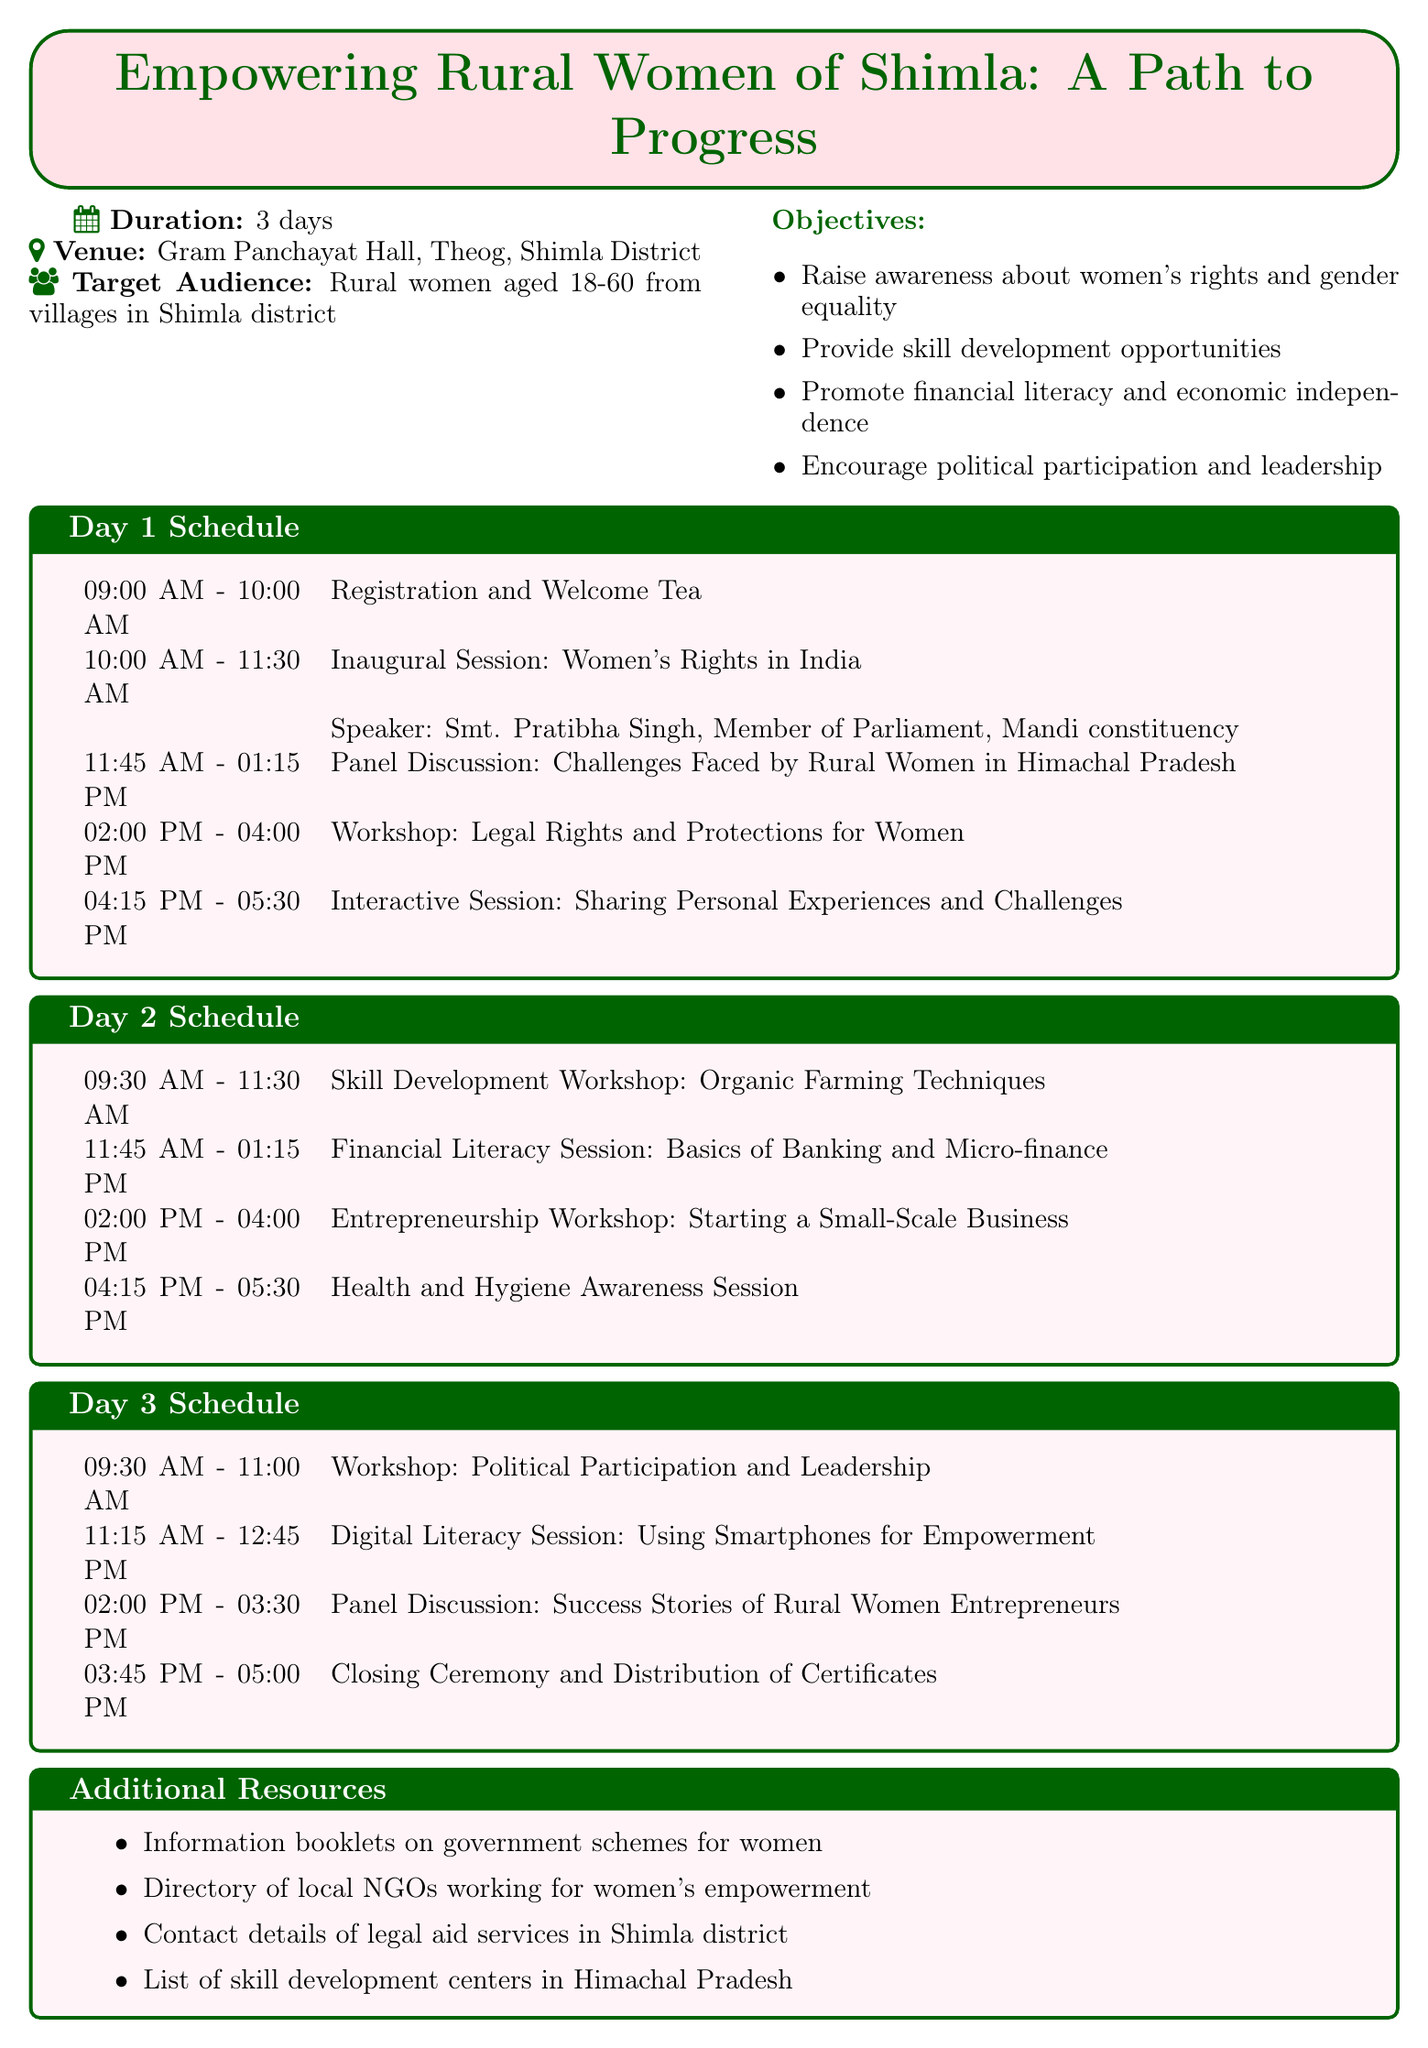What is the title of the workshop? The title is stated in the document as "Empowering Rural Women of Shimla: A Path to Progress."
Answer: Empowering Rural Women of Shimla: A Path to Progress What is the duration of the workshop? The duration is explicitly mentioned as "3 days."
Answer: 3 days Where is the venue located? The venue location is provided in the document as "Gram Panchayat Hall, Theog, Shimla District."
Answer: Gram Panchayat Hall, Theog, Shimla District Who is the speaker for the inaugural session? The document lists Smt. Pratibha Singh as the speaker for the inaugural session.
Answer: Smt. Pratibha Singh What time does the Financial Literacy Session start on Day Two? The schedule specifies that the Financial Literacy Session starts at "11:45 AM."
Answer: 11:45 AM Which facilitator leads the workshop on Political Participation and Leadership? The document states that Smt. Asha Kumari is the facilitator for this workshop.
Answer: Smt. Asha Kumari How many panelists are there in the Day One panel discussion? The document lists three panelists for the Day One discussion.
Answer: 3 What is one of the objectives of the workshop? The document provides multiple objectives; one is "Raise awareness about women's rights and gender equality."
Answer: Raise awareness about women's rights and gender equality What session takes place after the Health and Hygiene Awareness Session on Day Two? The next session after Health and Hygiene Awareness on Day Two is the "Entrepreneurship Workshop: Starting a Small-Scale Business."
Answer: Entrepreneurship Workshop: Starting a Small-Scale Business 